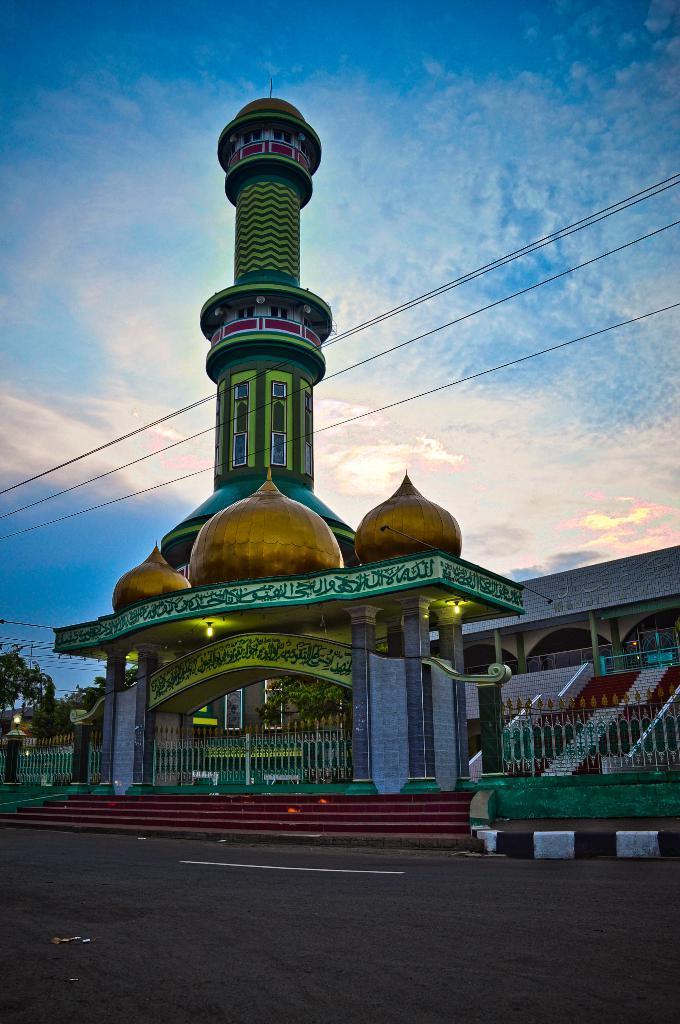Please provide a concise description of this image. In this image we can see a building with windows, gate, stairs, lights and a fence. We can also see the road, wires, trees and the sky which looks cloudy. 